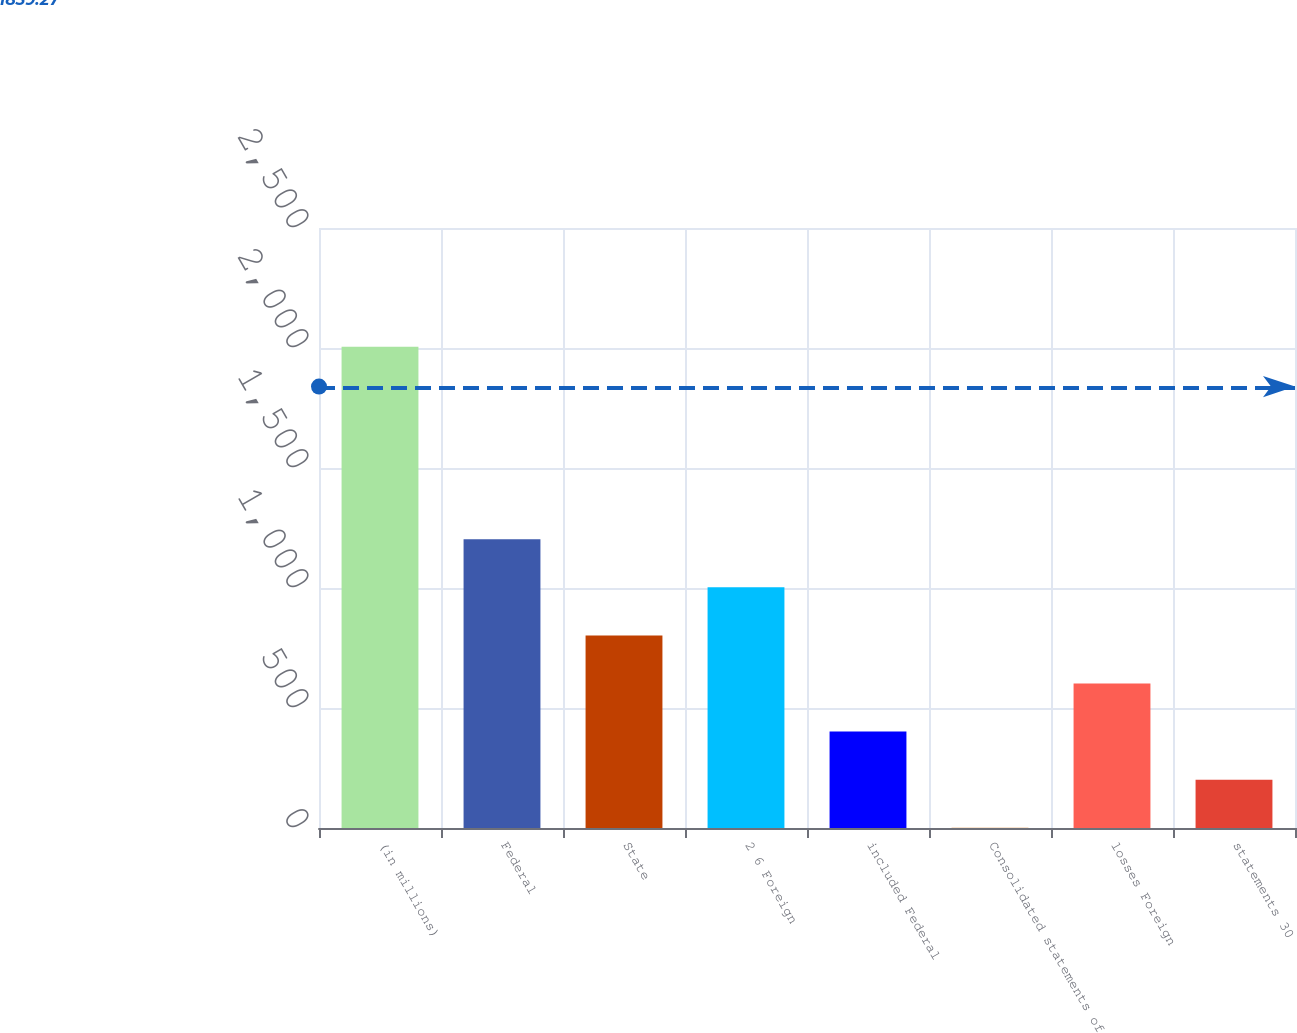Convert chart to OTSL. <chart><loc_0><loc_0><loc_500><loc_500><bar_chart><fcel>(in millions)<fcel>Federal<fcel>State<fcel>2 6 Foreign<fcel>included Federal<fcel>Consolidated statements of<fcel>losses Foreign<fcel>statements 30<nl><fcel>2005<fcel>1203.4<fcel>802.6<fcel>1003<fcel>401.8<fcel>1<fcel>602.2<fcel>201.4<nl></chart> 